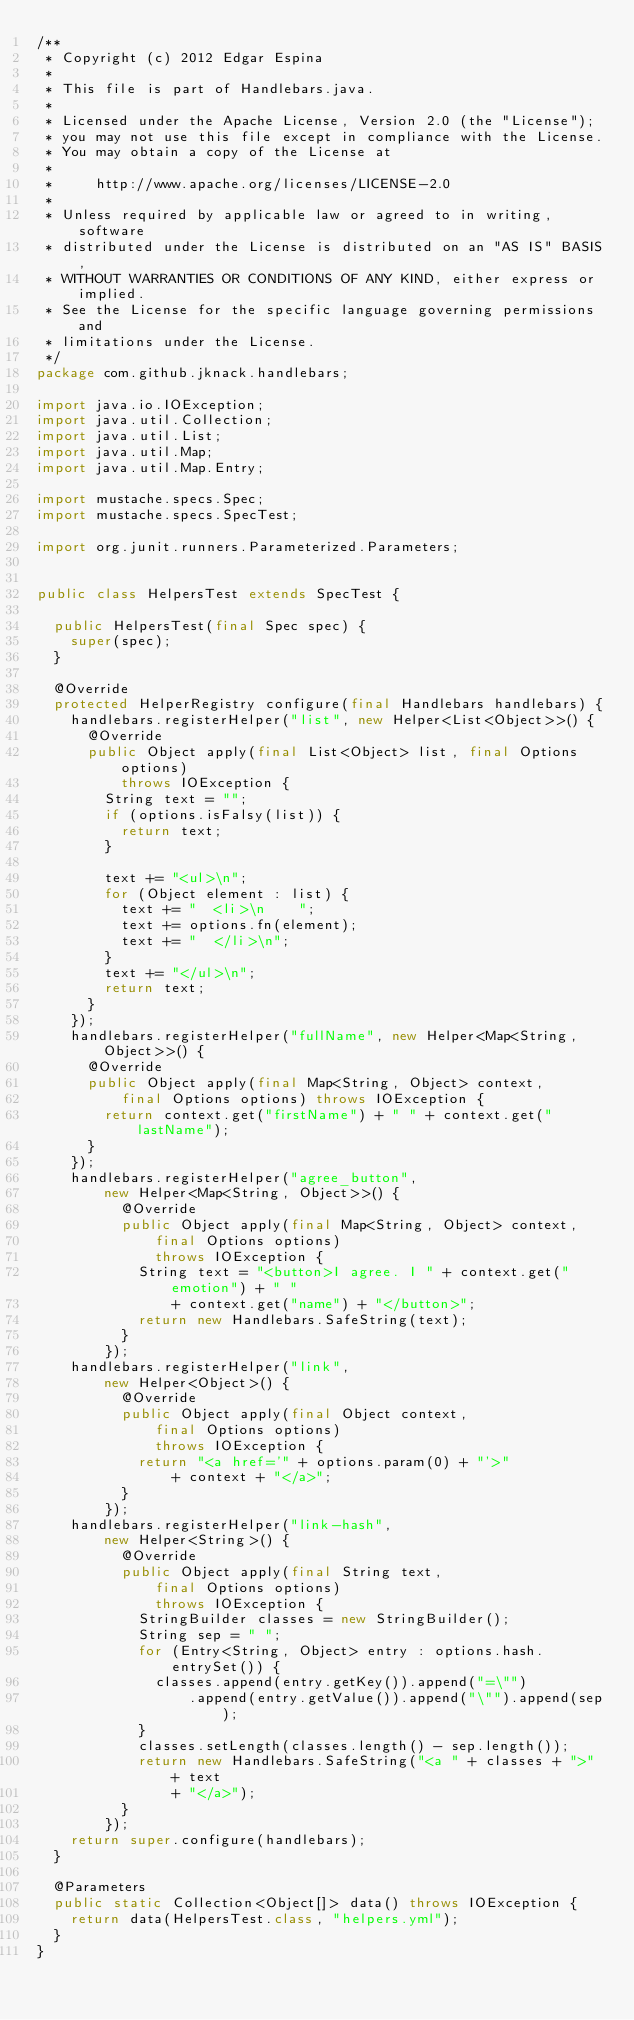Convert code to text. <code><loc_0><loc_0><loc_500><loc_500><_Java_>/**
 * Copyright (c) 2012 Edgar Espina
 *
 * This file is part of Handlebars.java.
 *
 * Licensed under the Apache License, Version 2.0 (the "License");
 * you may not use this file except in compliance with the License.
 * You may obtain a copy of the License at
 *
 *     http://www.apache.org/licenses/LICENSE-2.0
 *
 * Unless required by applicable law or agreed to in writing, software
 * distributed under the License is distributed on an "AS IS" BASIS,
 * WITHOUT WARRANTIES OR CONDITIONS OF ANY KIND, either express or implied.
 * See the License for the specific language governing permissions and
 * limitations under the License.
 */
package com.github.jknack.handlebars;

import java.io.IOException;
import java.util.Collection;
import java.util.List;
import java.util.Map;
import java.util.Map.Entry;

import mustache.specs.Spec;
import mustache.specs.SpecTest;

import org.junit.runners.Parameterized.Parameters;


public class HelpersTest extends SpecTest {

  public HelpersTest(final Spec spec) {
    super(spec);
  }

  @Override
  protected HelperRegistry configure(final Handlebars handlebars) {
    handlebars.registerHelper("list", new Helper<List<Object>>() {
      @Override
      public Object apply(final List<Object> list, final Options options)
          throws IOException {
        String text = "";
        if (options.isFalsy(list)) {
          return text;
        }

        text += "<ul>\n";
        for (Object element : list) {
          text += "  <li>\n    ";
          text += options.fn(element);
          text += "  </li>\n";
        }
        text += "</ul>\n";
        return text;
      }
    });
    handlebars.registerHelper("fullName", new Helper<Map<String, Object>>() {
      @Override
      public Object apply(final Map<String, Object> context,
          final Options options) throws IOException {
        return context.get("firstName") + " " + context.get("lastName");
      }
    });
    handlebars.registerHelper("agree_button",
        new Helper<Map<String, Object>>() {
          @Override
          public Object apply(final Map<String, Object> context,
              final Options options)
              throws IOException {
            String text = "<button>I agree. I " + context.get("emotion") + " "
                + context.get("name") + "</button>";
            return new Handlebars.SafeString(text);
          }
        });
    handlebars.registerHelper("link",
        new Helper<Object>() {
          @Override
          public Object apply(final Object context,
              final Options options)
              throws IOException {
            return "<a href='" + options.param(0) + "'>"
                + context + "</a>";
          }
        });
    handlebars.registerHelper("link-hash",
        new Helper<String>() {
          @Override
          public Object apply(final String text,
              final Options options)
              throws IOException {
            StringBuilder classes = new StringBuilder();
            String sep = " ";
            for (Entry<String, Object> entry : options.hash.entrySet()) {
              classes.append(entry.getKey()).append("=\"")
                  .append(entry.getValue()).append("\"").append(sep);
            }
            classes.setLength(classes.length() - sep.length());
            return new Handlebars.SafeString("<a " + classes + ">" + text
                + "</a>");
          }
        });
    return super.configure(handlebars);
  }

  @Parameters
  public static Collection<Object[]> data() throws IOException {
    return data(HelpersTest.class, "helpers.yml");
  }
}
</code> 